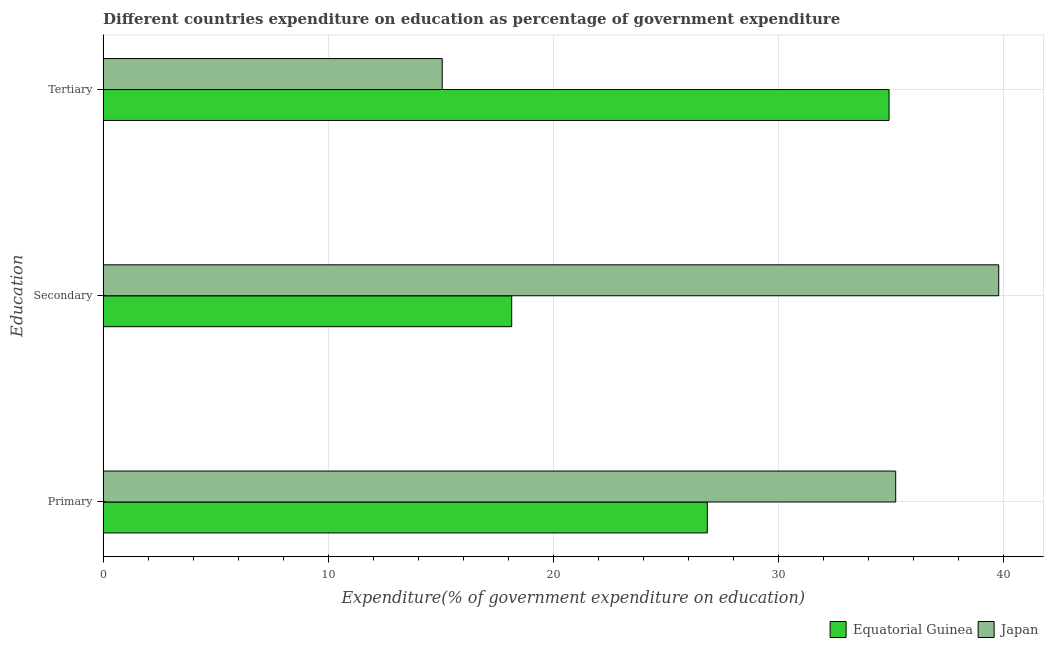How many different coloured bars are there?
Give a very brief answer. 2. How many groups of bars are there?
Provide a short and direct response. 3. Are the number of bars per tick equal to the number of legend labels?
Offer a terse response. Yes. How many bars are there on the 2nd tick from the bottom?
Your answer should be compact. 2. What is the label of the 3rd group of bars from the top?
Offer a terse response. Primary. What is the expenditure on primary education in Equatorial Guinea?
Make the answer very short. 26.84. Across all countries, what is the maximum expenditure on secondary education?
Provide a short and direct response. 39.78. Across all countries, what is the minimum expenditure on tertiary education?
Make the answer very short. 15.06. In which country was the expenditure on tertiary education maximum?
Your answer should be very brief. Equatorial Guinea. In which country was the expenditure on primary education minimum?
Your response must be concise. Equatorial Guinea. What is the total expenditure on primary education in the graph?
Your response must be concise. 62.05. What is the difference between the expenditure on secondary education in Equatorial Guinea and that in Japan?
Make the answer very short. -21.63. What is the difference between the expenditure on secondary education in Japan and the expenditure on tertiary education in Equatorial Guinea?
Your answer should be compact. 4.87. What is the average expenditure on secondary education per country?
Keep it short and to the point. 28.97. What is the difference between the expenditure on primary education and expenditure on secondary education in Equatorial Guinea?
Offer a very short reply. 8.69. What is the ratio of the expenditure on secondary education in Japan to that in Equatorial Guinea?
Ensure brevity in your answer.  2.19. Is the expenditure on secondary education in Equatorial Guinea less than that in Japan?
Make the answer very short. Yes. Is the difference between the expenditure on secondary education in Japan and Equatorial Guinea greater than the difference between the expenditure on primary education in Japan and Equatorial Guinea?
Provide a short and direct response. Yes. What is the difference between the highest and the second highest expenditure on primary education?
Keep it short and to the point. 8.37. What is the difference between the highest and the lowest expenditure on primary education?
Your answer should be very brief. 8.37. Is the sum of the expenditure on primary education in Equatorial Guinea and Japan greater than the maximum expenditure on secondary education across all countries?
Make the answer very short. Yes. What does the 1st bar from the top in Tertiary represents?
Make the answer very short. Japan. How many bars are there?
Keep it short and to the point. 6. How many countries are there in the graph?
Keep it short and to the point. 2. How many legend labels are there?
Your answer should be very brief. 2. How are the legend labels stacked?
Your answer should be compact. Horizontal. What is the title of the graph?
Keep it short and to the point. Different countries expenditure on education as percentage of government expenditure. Does "Oman" appear as one of the legend labels in the graph?
Your response must be concise. No. What is the label or title of the X-axis?
Provide a short and direct response. Expenditure(% of government expenditure on education). What is the label or title of the Y-axis?
Your answer should be very brief. Education. What is the Expenditure(% of government expenditure on education) of Equatorial Guinea in Primary?
Make the answer very short. 26.84. What is the Expenditure(% of government expenditure on education) of Japan in Primary?
Provide a short and direct response. 35.21. What is the Expenditure(% of government expenditure on education) of Equatorial Guinea in Secondary?
Keep it short and to the point. 18.15. What is the Expenditure(% of government expenditure on education) in Japan in Secondary?
Keep it short and to the point. 39.78. What is the Expenditure(% of government expenditure on education) in Equatorial Guinea in Tertiary?
Your answer should be compact. 34.91. What is the Expenditure(% of government expenditure on education) of Japan in Tertiary?
Provide a short and direct response. 15.06. Across all Education, what is the maximum Expenditure(% of government expenditure on education) of Equatorial Guinea?
Your answer should be very brief. 34.91. Across all Education, what is the maximum Expenditure(% of government expenditure on education) of Japan?
Give a very brief answer. 39.78. Across all Education, what is the minimum Expenditure(% of government expenditure on education) of Equatorial Guinea?
Make the answer very short. 18.15. Across all Education, what is the minimum Expenditure(% of government expenditure on education) in Japan?
Give a very brief answer. 15.06. What is the total Expenditure(% of government expenditure on education) in Equatorial Guinea in the graph?
Keep it short and to the point. 79.9. What is the total Expenditure(% of government expenditure on education) in Japan in the graph?
Your response must be concise. 90.05. What is the difference between the Expenditure(% of government expenditure on education) in Equatorial Guinea in Primary and that in Secondary?
Provide a succinct answer. 8.69. What is the difference between the Expenditure(% of government expenditure on education) of Japan in Primary and that in Secondary?
Make the answer very short. -4.58. What is the difference between the Expenditure(% of government expenditure on education) of Equatorial Guinea in Primary and that in Tertiary?
Offer a very short reply. -8.07. What is the difference between the Expenditure(% of government expenditure on education) in Japan in Primary and that in Tertiary?
Keep it short and to the point. 20.14. What is the difference between the Expenditure(% of government expenditure on education) in Equatorial Guinea in Secondary and that in Tertiary?
Your response must be concise. -16.76. What is the difference between the Expenditure(% of government expenditure on education) in Japan in Secondary and that in Tertiary?
Offer a terse response. 24.72. What is the difference between the Expenditure(% of government expenditure on education) in Equatorial Guinea in Primary and the Expenditure(% of government expenditure on education) in Japan in Secondary?
Ensure brevity in your answer.  -12.95. What is the difference between the Expenditure(% of government expenditure on education) in Equatorial Guinea in Primary and the Expenditure(% of government expenditure on education) in Japan in Tertiary?
Provide a succinct answer. 11.77. What is the difference between the Expenditure(% of government expenditure on education) of Equatorial Guinea in Secondary and the Expenditure(% of government expenditure on education) of Japan in Tertiary?
Make the answer very short. 3.09. What is the average Expenditure(% of government expenditure on education) in Equatorial Guinea per Education?
Keep it short and to the point. 26.63. What is the average Expenditure(% of government expenditure on education) of Japan per Education?
Offer a terse response. 30.02. What is the difference between the Expenditure(% of government expenditure on education) of Equatorial Guinea and Expenditure(% of government expenditure on education) of Japan in Primary?
Your answer should be compact. -8.37. What is the difference between the Expenditure(% of government expenditure on education) in Equatorial Guinea and Expenditure(% of government expenditure on education) in Japan in Secondary?
Your answer should be very brief. -21.63. What is the difference between the Expenditure(% of government expenditure on education) in Equatorial Guinea and Expenditure(% of government expenditure on education) in Japan in Tertiary?
Make the answer very short. 19.85. What is the ratio of the Expenditure(% of government expenditure on education) of Equatorial Guinea in Primary to that in Secondary?
Offer a very short reply. 1.48. What is the ratio of the Expenditure(% of government expenditure on education) in Japan in Primary to that in Secondary?
Your response must be concise. 0.89. What is the ratio of the Expenditure(% of government expenditure on education) of Equatorial Guinea in Primary to that in Tertiary?
Offer a very short reply. 0.77. What is the ratio of the Expenditure(% of government expenditure on education) in Japan in Primary to that in Tertiary?
Offer a very short reply. 2.34. What is the ratio of the Expenditure(% of government expenditure on education) of Equatorial Guinea in Secondary to that in Tertiary?
Give a very brief answer. 0.52. What is the ratio of the Expenditure(% of government expenditure on education) in Japan in Secondary to that in Tertiary?
Your response must be concise. 2.64. What is the difference between the highest and the second highest Expenditure(% of government expenditure on education) of Equatorial Guinea?
Offer a very short reply. 8.07. What is the difference between the highest and the second highest Expenditure(% of government expenditure on education) of Japan?
Your response must be concise. 4.58. What is the difference between the highest and the lowest Expenditure(% of government expenditure on education) of Equatorial Guinea?
Keep it short and to the point. 16.76. What is the difference between the highest and the lowest Expenditure(% of government expenditure on education) in Japan?
Your response must be concise. 24.72. 